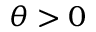<formula> <loc_0><loc_0><loc_500><loc_500>\theta > 0</formula> 